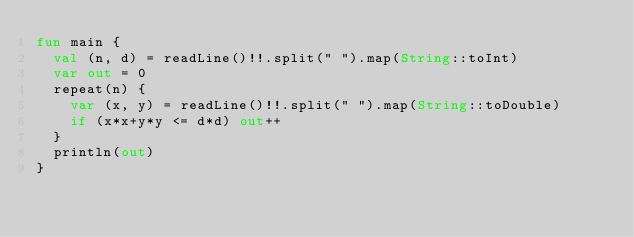<code> <loc_0><loc_0><loc_500><loc_500><_Kotlin_>fun main {
  val (n, d) = readLine()!!.split(" ").map(String::toInt)
  var out = 0
  repeat(n) {
    var (x, y) = readLine()!!.split(" ").map(String::toDouble)
    if (x*x+y*y <= d*d) out++
  }
  println(out)
}</code> 